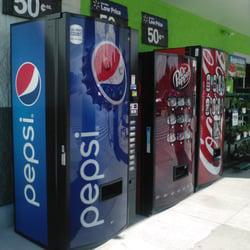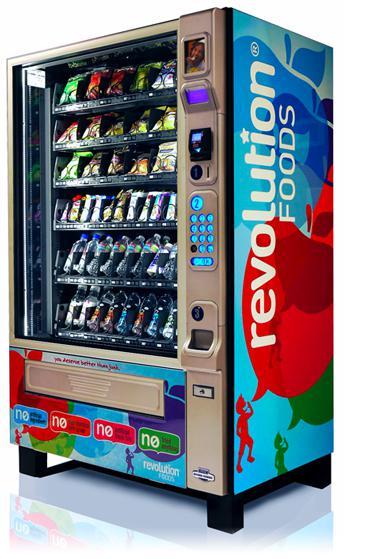The first image is the image on the left, the second image is the image on the right. Considering the images on both sides, is "The vending machine in the right image is predominately green." valid? Answer yes or no. No. The first image is the image on the left, the second image is the image on the right. Examine the images to the left and right. Is the description "An image features a standalone vending machine with greenish sides that include a logo towards the top." accurate? Answer yes or no. No. 